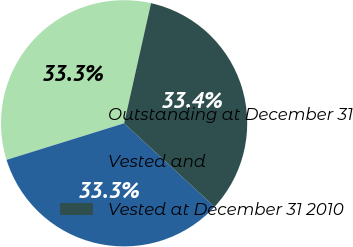Convert chart. <chart><loc_0><loc_0><loc_500><loc_500><pie_chart><fcel>Outstanding at December 31<fcel>Vested and<fcel>Vested at December 31 2010<nl><fcel>33.31%<fcel>33.33%<fcel>33.36%<nl></chart> 